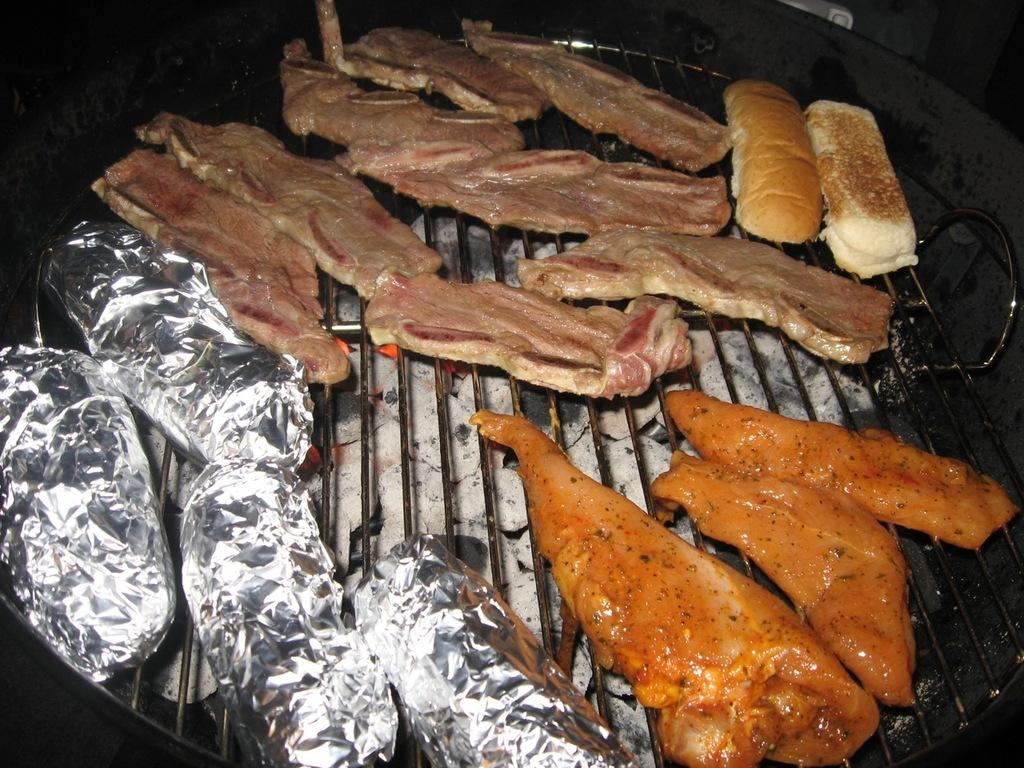What type of food is present in the image? There is raw meat in the image. Are there any other food items visible in the image? Yes, there are wrapped pieces in the image. What is being cooked on the grill in the image? There is bread on the grill in the image. What is providing heat for the grill in the image? Burning coal is visible beneath a girl in the image. How does the girl attempt to transport the cannon in the image? There is no cannon present in the image, and the girl is not attempting to transport anything. 